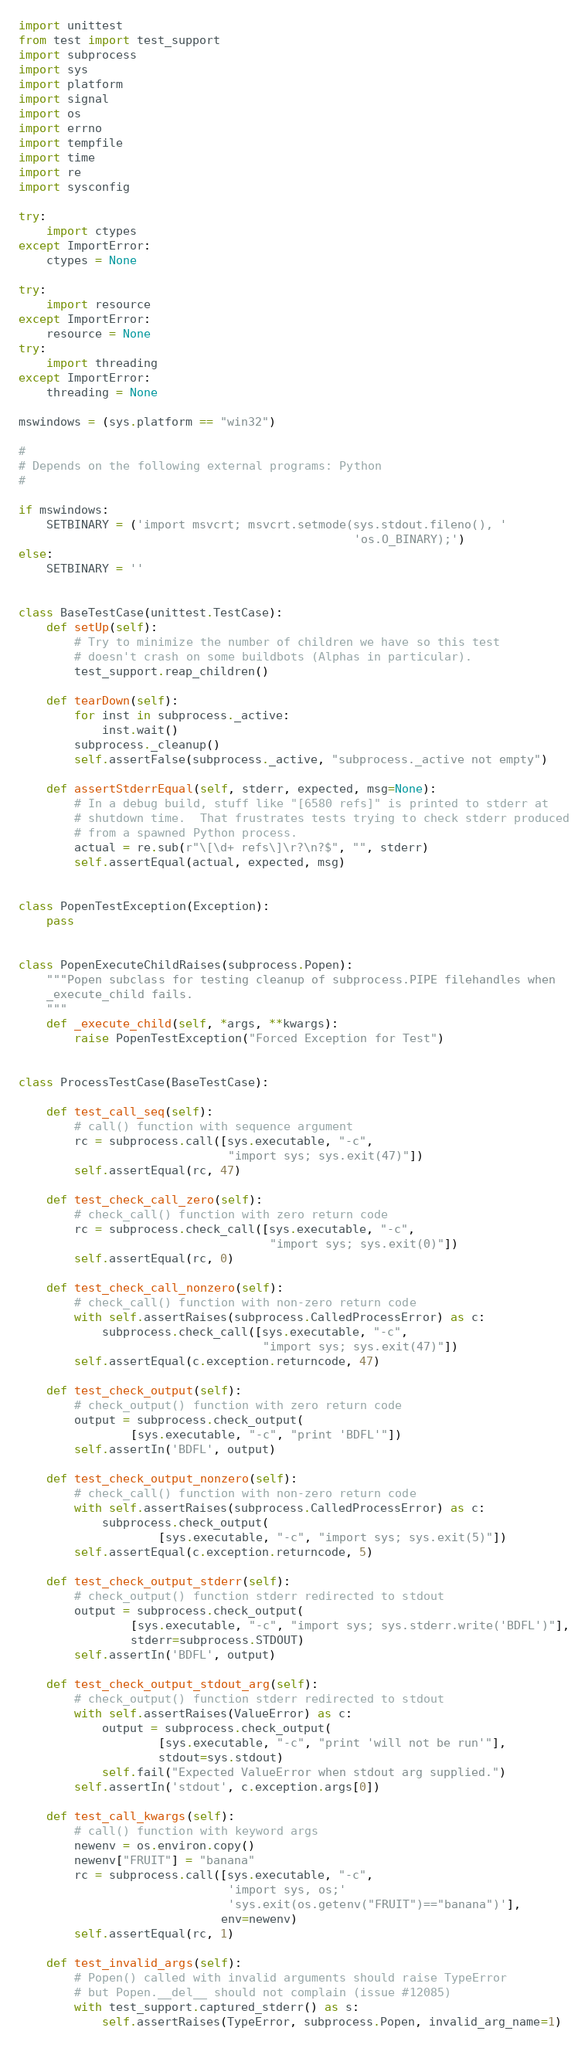<code> <loc_0><loc_0><loc_500><loc_500><_Python_>import unittest
from test import test_support
import subprocess
import sys
import platform
import signal
import os
import errno
import tempfile
import time
import re
import sysconfig

try:
    import ctypes
except ImportError:
    ctypes = None

try:
    import resource
except ImportError:
    resource = None
try:
    import threading
except ImportError:
    threading = None

mswindows = (sys.platform == "win32")

#
# Depends on the following external programs: Python
#

if mswindows:
    SETBINARY = ('import msvcrt; msvcrt.setmode(sys.stdout.fileno(), '
                                                'os.O_BINARY);')
else:
    SETBINARY = ''


class BaseTestCase(unittest.TestCase):
    def setUp(self):
        # Try to minimize the number of children we have so this test
        # doesn't crash on some buildbots (Alphas in particular).
        test_support.reap_children()

    def tearDown(self):
        for inst in subprocess._active:
            inst.wait()
        subprocess._cleanup()
        self.assertFalse(subprocess._active, "subprocess._active not empty")

    def assertStderrEqual(self, stderr, expected, msg=None):
        # In a debug build, stuff like "[6580 refs]" is printed to stderr at
        # shutdown time.  That frustrates tests trying to check stderr produced
        # from a spawned Python process.
        actual = re.sub(r"\[\d+ refs\]\r?\n?$", "", stderr)
        self.assertEqual(actual, expected, msg)


class PopenTestException(Exception):
    pass


class PopenExecuteChildRaises(subprocess.Popen):
    """Popen subclass for testing cleanup of subprocess.PIPE filehandles when
    _execute_child fails.
    """
    def _execute_child(self, *args, **kwargs):
        raise PopenTestException("Forced Exception for Test")


class ProcessTestCase(BaseTestCase):

    def test_call_seq(self):
        # call() function with sequence argument
        rc = subprocess.call([sys.executable, "-c",
                              "import sys; sys.exit(47)"])
        self.assertEqual(rc, 47)

    def test_check_call_zero(self):
        # check_call() function with zero return code
        rc = subprocess.check_call([sys.executable, "-c",
                                    "import sys; sys.exit(0)"])
        self.assertEqual(rc, 0)

    def test_check_call_nonzero(self):
        # check_call() function with non-zero return code
        with self.assertRaises(subprocess.CalledProcessError) as c:
            subprocess.check_call([sys.executable, "-c",
                                   "import sys; sys.exit(47)"])
        self.assertEqual(c.exception.returncode, 47)

    def test_check_output(self):
        # check_output() function with zero return code
        output = subprocess.check_output(
                [sys.executable, "-c", "print 'BDFL'"])
        self.assertIn('BDFL', output)

    def test_check_output_nonzero(self):
        # check_call() function with non-zero return code
        with self.assertRaises(subprocess.CalledProcessError) as c:
            subprocess.check_output(
                    [sys.executable, "-c", "import sys; sys.exit(5)"])
        self.assertEqual(c.exception.returncode, 5)

    def test_check_output_stderr(self):
        # check_output() function stderr redirected to stdout
        output = subprocess.check_output(
                [sys.executable, "-c", "import sys; sys.stderr.write('BDFL')"],
                stderr=subprocess.STDOUT)
        self.assertIn('BDFL', output)

    def test_check_output_stdout_arg(self):
        # check_output() function stderr redirected to stdout
        with self.assertRaises(ValueError) as c:
            output = subprocess.check_output(
                    [sys.executable, "-c", "print 'will not be run'"],
                    stdout=sys.stdout)
            self.fail("Expected ValueError when stdout arg supplied.")
        self.assertIn('stdout', c.exception.args[0])

    def test_call_kwargs(self):
        # call() function with keyword args
        newenv = os.environ.copy()
        newenv["FRUIT"] = "banana"
        rc = subprocess.call([sys.executable, "-c",
                              'import sys, os;'
                              'sys.exit(os.getenv("FRUIT")=="banana")'],
                             env=newenv)
        self.assertEqual(rc, 1)

    def test_invalid_args(self):
        # Popen() called with invalid arguments should raise TypeError
        # but Popen.__del__ should not complain (issue #12085)
        with test_support.captured_stderr() as s:
            self.assertRaises(TypeError, subprocess.Popen, invalid_arg_name=1)</code> 